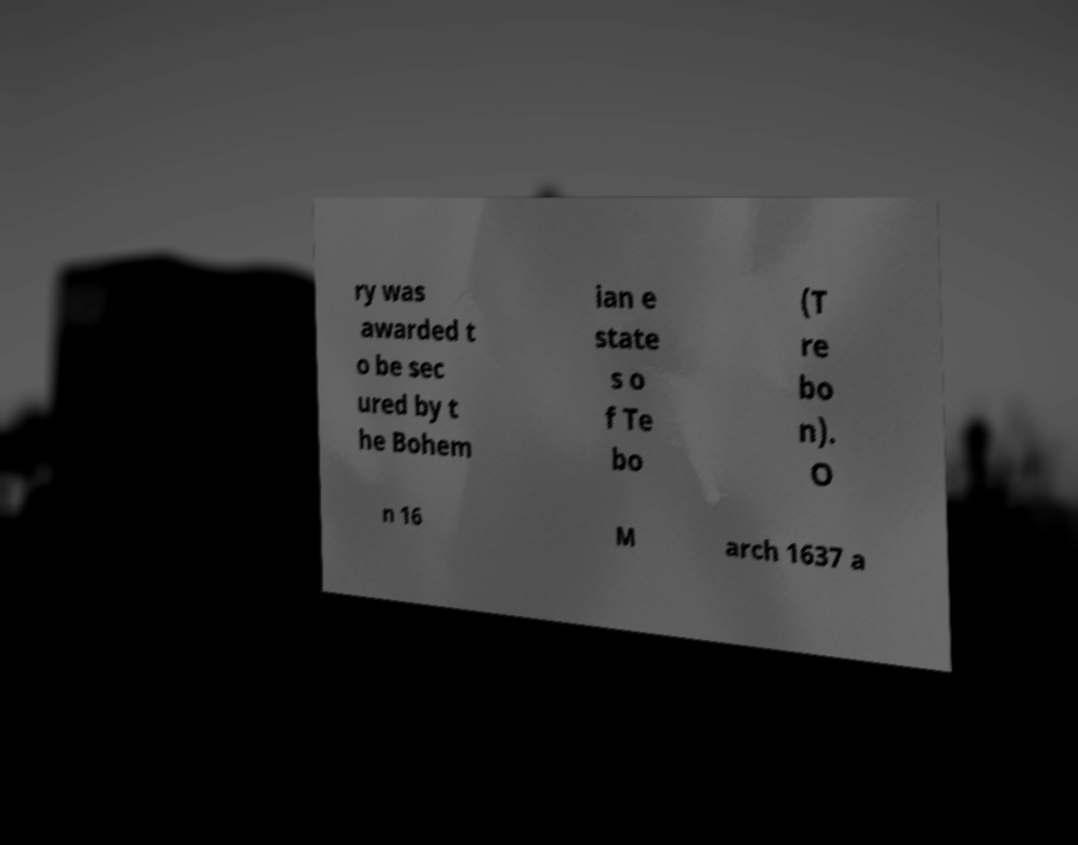Can you accurately transcribe the text from the provided image for me? ry was awarded t o be sec ured by t he Bohem ian e state s o f Te bo (T re bo n). O n 16 M arch 1637 a 